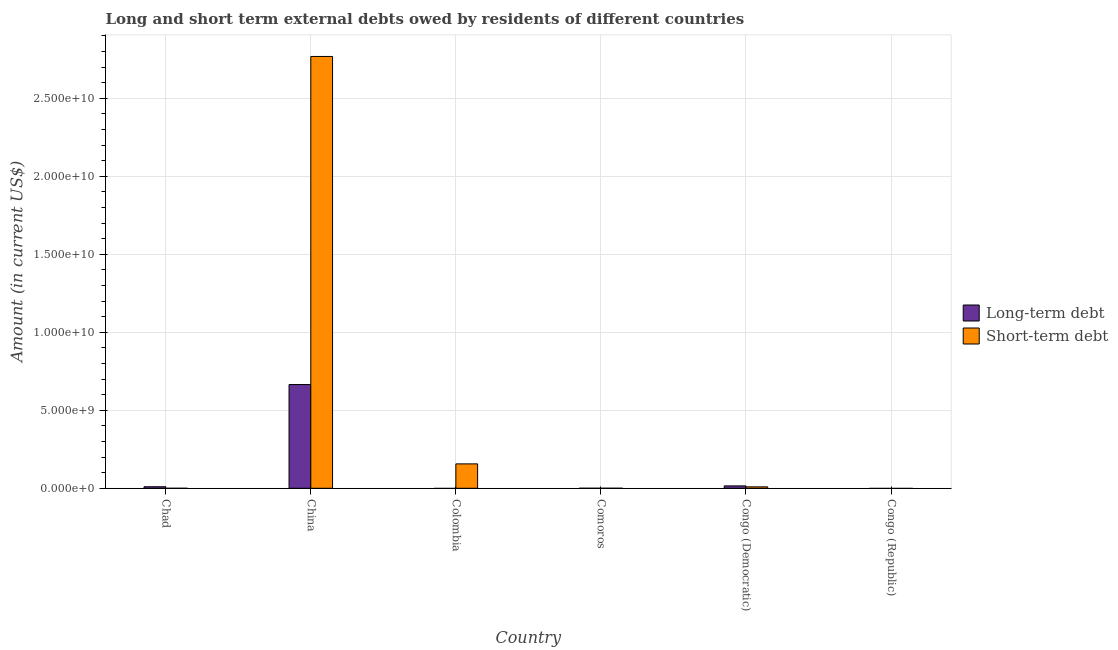How many different coloured bars are there?
Your answer should be compact. 2. Are the number of bars per tick equal to the number of legend labels?
Give a very brief answer. No. Are the number of bars on each tick of the X-axis equal?
Ensure brevity in your answer.  No. What is the label of the 4th group of bars from the left?
Your response must be concise. Comoros. What is the long-term debts owed by residents in Comoros?
Make the answer very short. 1.25e+06. Across all countries, what is the maximum short-term debts owed by residents?
Your answer should be very brief. 2.77e+1. Across all countries, what is the minimum short-term debts owed by residents?
Ensure brevity in your answer.  0. What is the total long-term debts owed by residents in the graph?
Provide a short and direct response. 6.90e+09. What is the difference between the long-term debts owed by residents in China and that in Comoros?
Your response must be concise. 6.65e+09. What is the difference between the short-term debts owed by residents in Congo (Republic) and the long-term debts owed by residents in Comoros?
Ensure brevity in your answer.  -1.25e+06. What is the average long-term debts owed by residents per country?
Provide a succinct answer. 1.15e+09. What is the difference between the short-term debts owed by residents and long-term debts owed by residents in China?
Ensure brevity in your answer.  2.10e+1. What is the ratio of the long-term debts owed by residents in Comoros to that in Congo (Democratic)?
Ensure brevity in your answer.  0.01. What is the difference between the highest and the second highest long-term debts owed by residents?
Make the answer very short. 6.50e+09. What is the difference between the highest and the lowest short-term debts owed by residents?
Provide a succinct answer. 2.77e+1. How many bars are there?
Offer a terse response. 8. How many countries are there in the graph?
Your response must be concise. 6. What is the difference between two consecutive major ticks on the Y-axis?
Make the answer very short. 5.00e+09. Are the values on the major ticks of Y-axis written in scientific E-notation?
Give a very brief answer. Yes. Does the graph contain any zero values?
Give a very brief answer. Yes. Does the graph contain grids?
Ensure brevity in your answer.  Yes. How many legend labels are there?
Your answer should be compact. 2. How are the legend labels stacked?
Provide a short and direct response. Vertical. What is the title of the graph?
Make the answer very short. Long and short term external debts owed by residents of different countries. Does "Highest 10% of population" appear as one of the legend labels in the graph?
Offer a very short reply. No. What is the label or title of the Y-axis?
Your answer should be compact. Amount (in current US$). What is the Amount (in current US$) in Long-term debt in Chad?
Your response must be concise. 9.87e+07. What is the Amount (in current US$) in Long-term debt in China?
Ensure brevity in your answer.  6.65e+09. What is the Amount (in current US$) in Short-term debt in China?
Offer a terse response. 2.77e+1. What is the Amount (in current US$) of Long-term debt in Colombia?
Your answer should be very brief. 0. What is the Amount (in current US$) of Short-term debt in Colombia?
Make the answer very short. 1.56e+09. What is the Amount (in current US$) in Long-term debt in Comoros?
Offer a very short reply. 1.25e+06. What is the Amount (in current US$) in Short-term debt in Comoros?
Your response must be concise. 1.94e+06. What is the Amount (in current US$) of Long-term debt in Congo (Democratic)?
Give a very brief answer. 1.53e+08. What is the Amount (in current US$) in Short-term debt in Congo (Democratic)?
Give a very brief answer. 9.20e+07. Across all countries, what is the maximum Amount (in current US$) in Long-term debt?
Give a very brief answer. 6.65e+09. Across all countries, what is the maximum Amount (in current US$) of Short-term debt?
Provide a succinct answer. 2.77e+1. Across all countries, what is the minimum Amount (in current US$) of Short-term debt?
Make the answer very short. 0. What is the total Amount (in current US$) in Long-term debt in the graph?
Make the answer very short. 6.90e+09. What is the total Amount (in current US$) in Short-term debt in the graph?
Your answer should be compact. 2.93e+1. What is the difference between the Amount (in current US$) of Long-term debt in Chad and that in China?
Give a very brief answer. -6.55e+09. What is the difference between the Amount (in current US$) of Long-term debt in Chad and that in Comoros?
Provide a short and direct response. 9.74e+07. What is the difference between the Amount (in current US$) of Long-term debt in Chad and that in Congo (Democratic)?
Make the answer very short. -5.39e+07. What is the difference between the Amount (in current US$) in Short-term debt in China and that in Colombia?
Offer a terse response. 2.61e+1. What is the difference between the Amount (in current US$) of Long-term debt in China and that in Comoros?
Offer a very short reply. 6.65e+09. What is the difference between the Amount (in current US$) in Short-term debt in China and that in Comoros?
Your response must be concise. 2.77e+1. What is the difference between the Amount (in current US$) in Long-term debt in China and that in Congo (Democratic)?
Your answer should be very brief. 6.50e+09. What is the difference between the Amount (in current US$) of Short-term debt in China and that in Congo (Democratic)?
Offer a terse response. 2.76e+1. What is the difference between the Amount (in current US$) of Short-term debt in Colombia and that in Comoros?
Your response must be concise. 1.56e+09. What is the difference between the Amount (in current US$) of Short-term debt in Colombia and that in Congo (Democratic)?
Provide a short and direct response. 1.47e+09. What is the difference between the Amount (in current US$) in Long-term debt in Comoros and that in Congo (Democratic)?
Provide a succinct answer. -1.51e+08. What is the difference between the Amount (in current US$) in Short-term debt in Comoros and that in Congo (Democratic)?
Keep it short and to the point. -9.01e+07. What is the difference between the Amount (in current US$) of Long-term debt in Chad and the Amount (in current US$) of Short-term debt in China?
Offer a very short reply. -2.76e+1. What is the difference between the Amount (in current US$) in Long-term debt in Chad and the Amount (in current US$) in Short-term debt in Colombia?
Give a very brief answer. -1.46e+09. What is the difference between the Amount (in current US$) of Long-term debt in Chad and the Amount (in current US$) of Short-term debt in Comoros?
Offer a terse response. 9.67e+07. What is the difference between the Amount (in current US$) in Long-term debt in Chad and the Amount (in current US$) in Short-term debt in Congo (Democratic)?
Give a very brief answer. 6.67e+06. What is the difference between the Amount (in current US$) in Long-term debt in China and the Amount (in current US$) in Short-term debt in Colombia?
Make the answer very short. 5.09e+09. What is the difference between the Amount (in current US$) of Long-term debt in China and the Amount (in current US$) of Short-term debt in Comoros?
Ensure brevity in your answer.  6.65e+09. What is the difference between the Amount (in current US$) in Long-term debt in China and the Amount (in current US$) in Short-term debt in Congo (Democratic)?
Offer a terse response. 6.56e+09. What is the difference between the Amount (in current US$) of Long-term debt in Comoros and the Amount (in current US$) of Short-term debt in Congo (Democratic)?
Keep it short and to the point. -9.08e+07. What is the average Amount (in current US$) of Long-term debt per country?
Offer a very short reply. 1.15e+09. What is the average Amount (in current US$) of Short-term debt per country?
Keep it short and to the point. 4.89e+09. What is the difference between the Amount (in current US$) of Long-term debt and Amount (in current US$) of Short-term debt in China?
Your response must be concise. -2.10e+1. What is the difference between the Amount (in current US$) of Long-term debt and Amount (in current US$) of Short-term debt in Comoros?
Give a very brief answer. -6.86e+05. What is the difference between the Amount (in current US$) in Long-term debt and Amount (in current US$) in Short-term debt in Congo (Democratic)?
Make the answer very short. 6.06e+07. What is the ratio of the Amount (in current US$) of Long-term debt in Chad to that in China?
Give a very brief answer. 0.01. What is the ratio of the Amount (in current US$) in Long-term debt in Chad to that in Comoros?
Ensure brevity in your answer.  78.93. What is the ratio of the Amount (in current US$) in Long-term debt in Chad to that in Congo (Democratic)?
Your answer should be very brief. 0.65. What is the ratio of the Amount (in current US$) in Short-term debt in China to that in Colombia?
Give a very brief answer. 17.7. What is the ratio of the Amount (in current US$) of Long-term debt in China to that in Comoros?
Your response must be concise. 5319.31. What is the ratio of the Amount (in current US$) in Short-term debt in China to that in Comoros?
Provide a short and direct response. 1.43e+04. What is the ratio of the Amount (in current US$) in Long-term debt in China to that in Congo (Democratic)?
Give a very brief answer. 43.57. What is the ratio of the Amount (in current US$) of Short-term debt in China to that in Congo (Democratic)?
Provide a short and direct response. 300.84. What is the ratio of the Amount (in current US$) of Short-term debt in Colombia to that in Comoros?
Make the answer very short. 807.64. What is the ratio of the Amount (in current US$) in Short-term debt in Colombia to that in Congo (Democratic)?
Your answer should be very brief. 17. What is the ratio of the Amount (in current US$) of Long-term debt in Comoros to that in Congo (Democratic)?
Keep it short and to the point. 0.01. What is the ratio of the Amount (in current US$) in Short-term debt in Comoros to that in Congo (Democratic)?
Make the answer very short. 0.02. What is the difference between the highest and the second highest Amount (in current US$) of Long-term debt?
Give a very brief answer. 6.50e+09. What is the difference between the highest and the second highest Amount (in current US$) of Short-term debt?
Provide a succinct answer. 2.61e+1. What is the difference between the highest and the lowest Amount (in current US$) of Long-term debt?
Provide a succinct answer. 6.65e+09. What is the difference between the highest and the lowest Amount (in current US$) in Short-term debt?
Make the answer very short. 2.77e+1. 